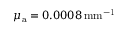<formula> <loc_0><loc_0><loc_500><loc_500>\mu _ { \mathrm a } = 0 . 0 0 0 8 \, { m m } ^ { - 1 }</formula> 